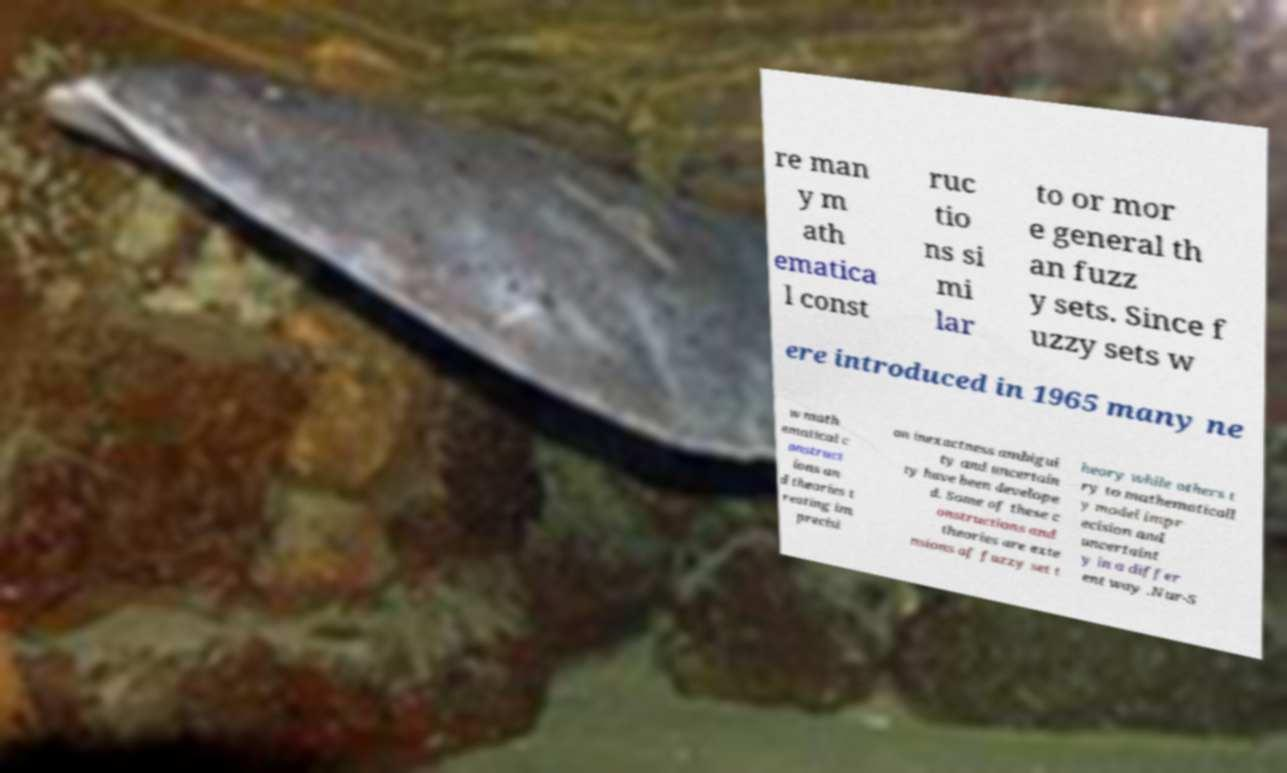Please identify and transcribe the text found in this image. re man y m ath ematica l const ruc tio ns si mi lar to or mor e general th an fuzz y sets. Since f uzzy sets w ere introduced in 1965 many ne w math ematical c onstruct ions an d theories t reating im precisi on inexactness ambigui ty and uncertain ty have been develope d. Some of these c onstructions and theories are exte nsions of fuzzy set t heory while others t ry to mathematicall y model impr ecision and uncertaint y in a differ ent way .Nur-S 